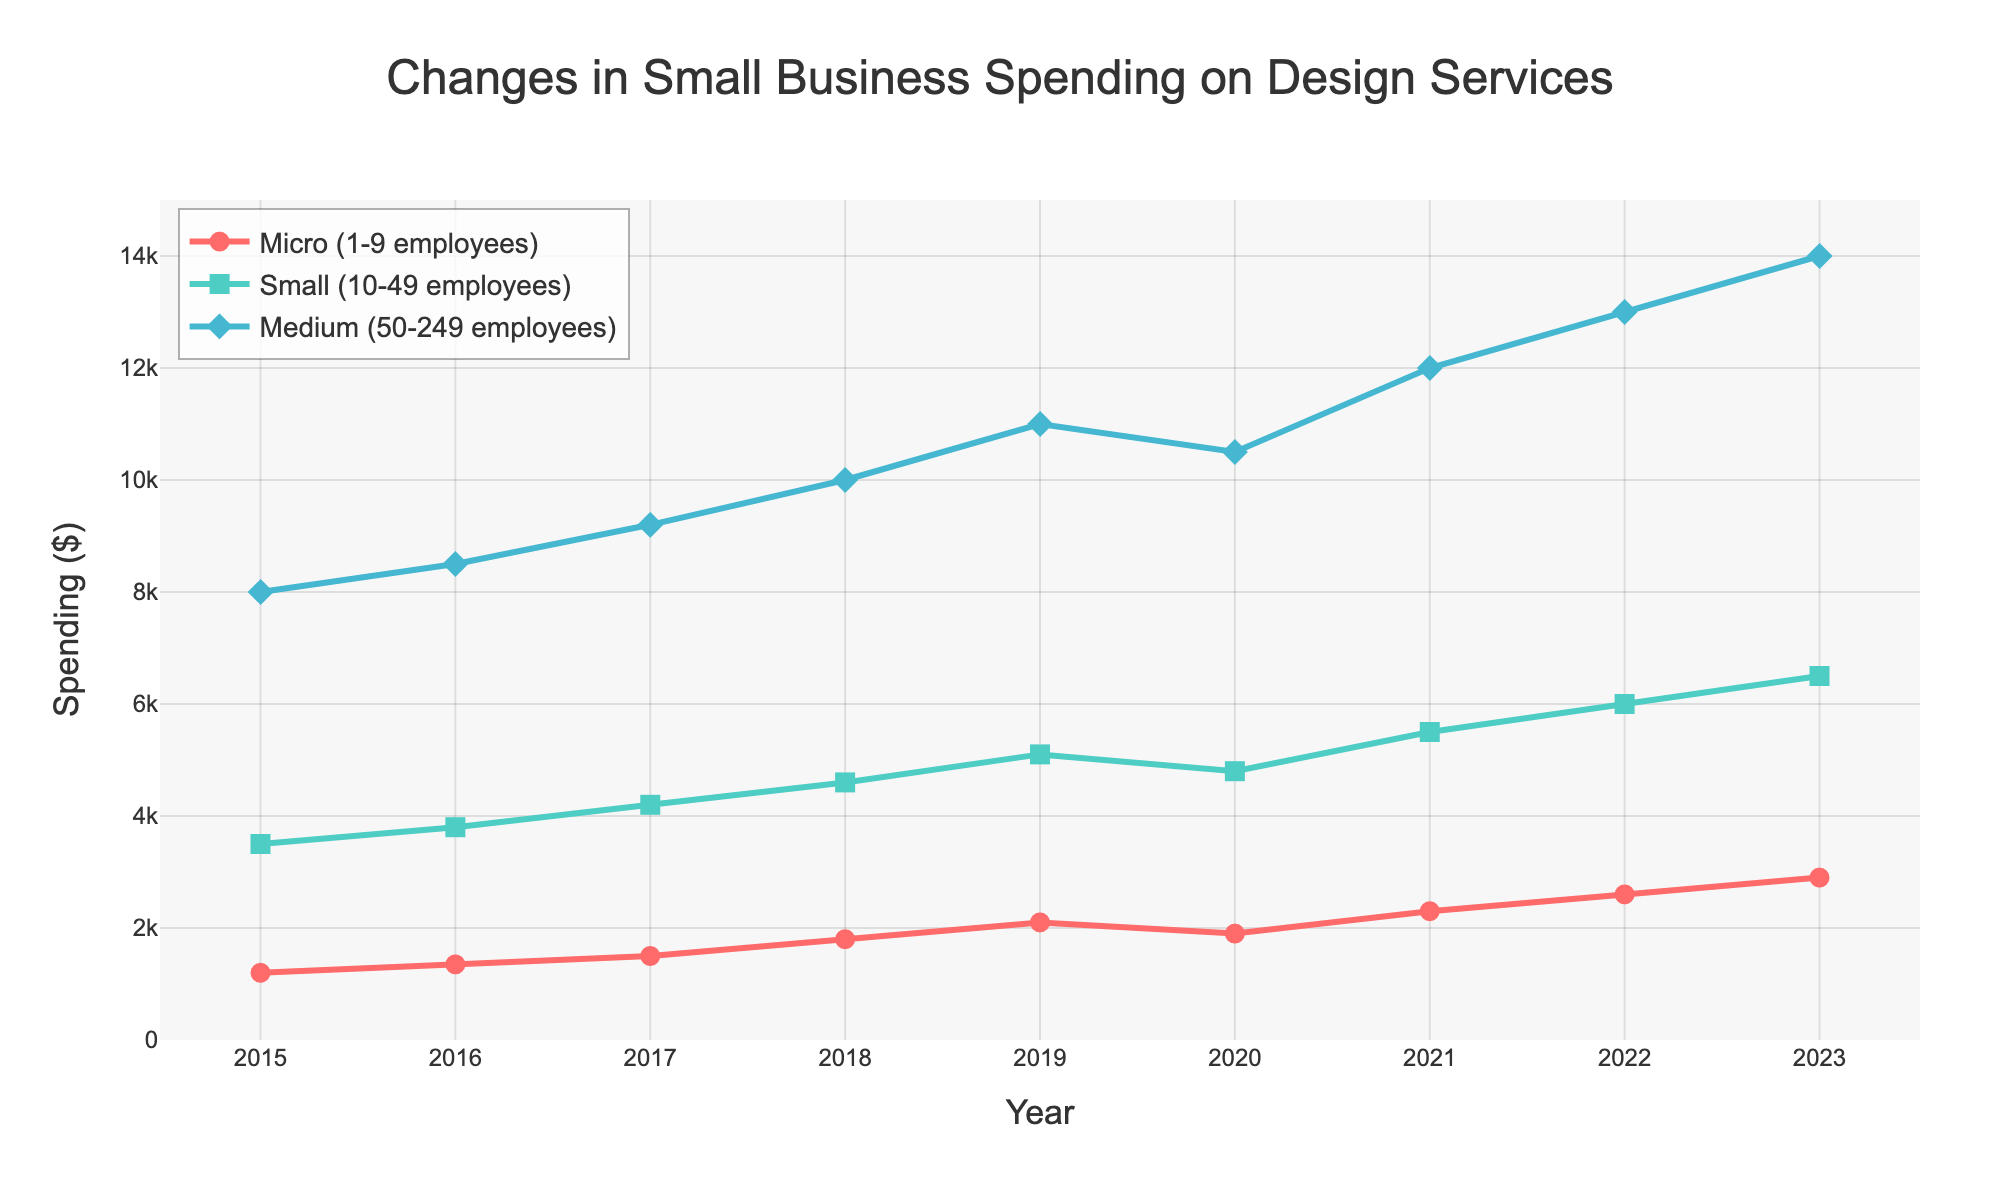What is the total spending on design services by Micro businesses in 2019 and 2020? The spending in 2019 by Micro businesses is $2100, and in 2020, it's $1900. The total spending is $2100 + $1900 = $4000.
Answer: $4000 Which company size had the highest increase in spending from 2015 to 2023? To find the highest increase, subtract the spending in 2015 from 2023 for each company size. Micro: 2900 - 1200 = 1700, Small: 6500 - 3500 = 3000, Medium: 14000 - 8000 = 6000. The Medium company size has the highest increase of $6000.
Answer: Medium What is the average spending on design services by Small businesses over the years shown in the chart? Add all the yearly spending values for Small businesses and divide by the number of years. (3500 + 3800 + 4200 + 4600 + 5100 + 4800 + 5500 + 6000 + 6500) / 9 = 5333.33
Answer: $5333.33 Which year saw the biggest drop in spending for Micro businesses? Compare yearly changes: 2016-2015 = 150, 2017-2016 = 150, 2018-2017 = 300, 2019-2018 = 300, 2020-2019 = -200, 2021-2020 = 400, 2022-2021 = 300, 2023-2022 = 300. The year with the biggest drop is 2020 with a decrease of $200.
Answer: 2020 Between Small and Medium companies, who spent more on design services in 2021? From the chart, Small companies spent $5500 in 2021, and Medium companies spent $12000. Medium companies spent more.
Answer: Medium Visualize the trend for Small business spending: what is the color and shape used to represent this data? According to the legend, Small business spending is represented by green color and square markers.
Answer: Green and square In 2023, how much more did Medium businesses spend compared to Micro businesses? Subtract Micro spending in 2023 from Medium spending in 2023. $14000 - $2900 = $11100
Answer: $11100 What is the year with the smallest spending difference between Small and Medium businesses? Calculate the yearly difference between Small and Medium: 2015 = 4500, 2016 = 4700, 2017 = 5000, 2018 = 5400, 2019 = 5900, 2020 = 5700, 2021 = 6500, 2022 = 7000, 2023 = 7500. The smallest difference is in 2015 with $4500.
Answer: 2015 